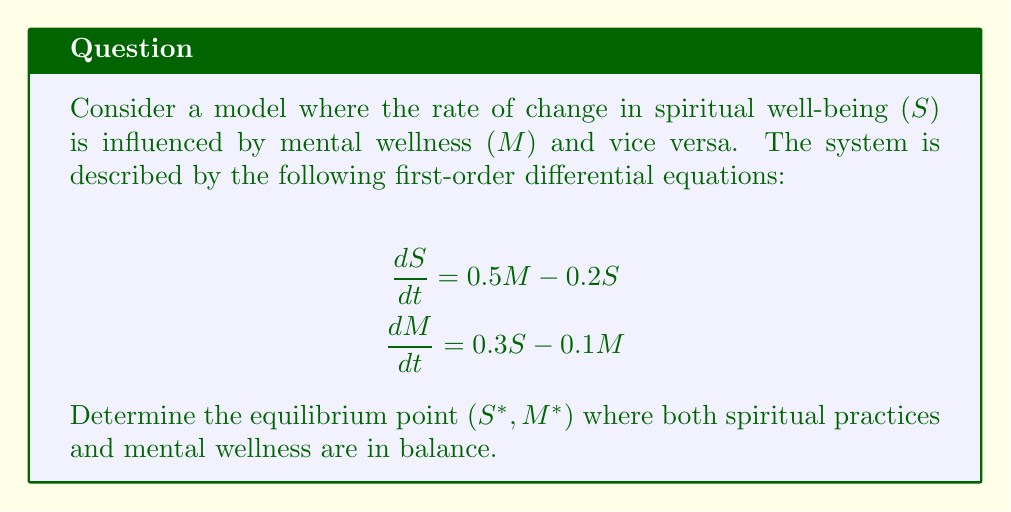Help me with this question. To find the equilibrium point, we need to set both derivatives to zero and solve the resulting system of equations:

1) Set $\frac{dS}{dt} = 0$ and $\frac{dM}{dt} = 0$:

   $$0 = 0.5M - 0.2S$$
   $$0 = 0.3S - 0.1M$$

2) From the first equation:
   $$0.2S = 0.5M$$
   $$S = \frac{5M}{2}$$

3) Substitute this into the second equation:
   $$0 = 0.3(\frac{5M}{2}) - 0.1M$$
   $$0 = 0.75M - 0.1M$$
   $$0 = 0.65M$$

4) Solve for $M$:
   $$M = 0$$

5) Substitute back to find $S$:
   $$S = \frac{5(0)}{2} = 0$$

Therefore, the equilibrium point is $(S^*, M^*) = (0, 0)$.

This equilibrium point represents a state where both spiritual well-being and mental wellness are at a baseline level, indicating a balance between spiritual practices and mental health.
Answer: The equilibrium point is $(S^*, M^*) = (0, 0)$. 